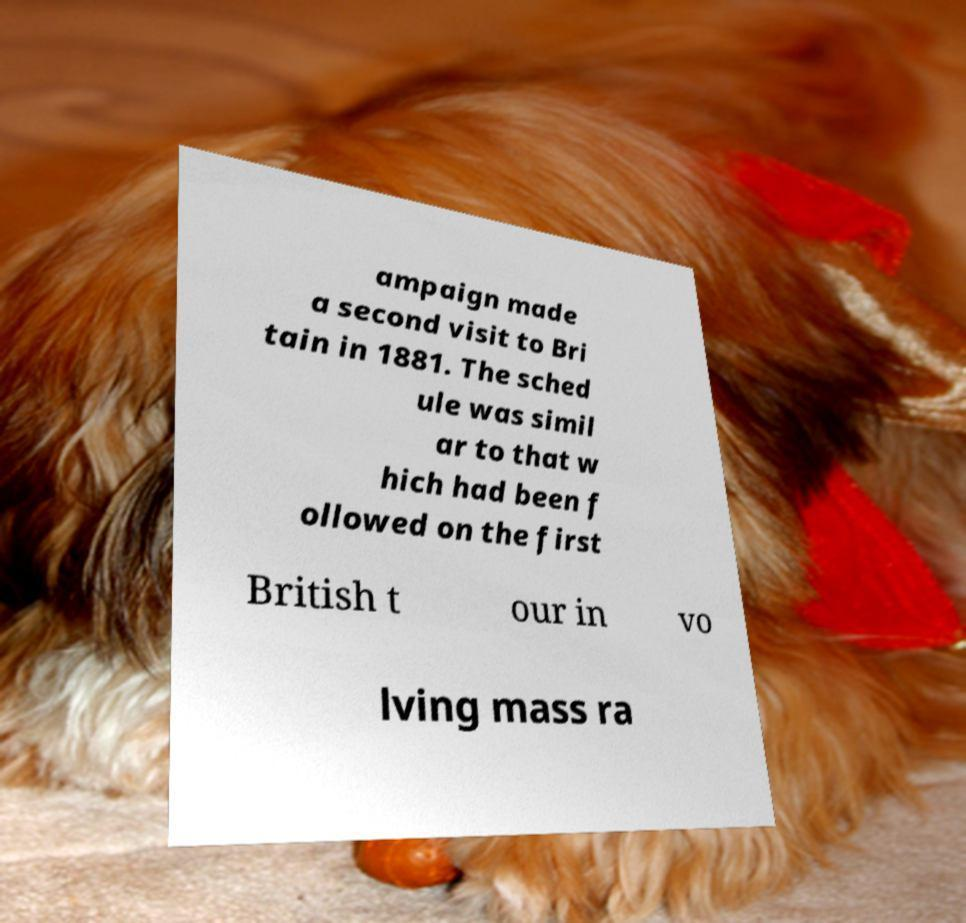Could you extract and type out the text from this image? ampaign made a second visit to Bri tain in 1881. The sched ule was simil ar to that w hich had been f ollowed on the first British t our in vo lving mass ra 